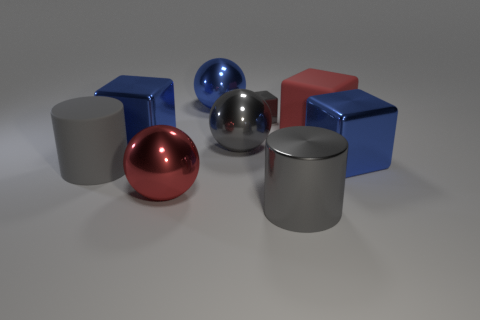Subtract 2 blocks. How many blocks are left? 2 Subtract all gray blocks. How many blocks are left? 3 Subtract all red cubes. How many cubes are left? 3 Subtract all cyan cubes. Subtract all red cylinders. How many cubes are left? 4 Add 1 small cyan things. How many objects exist? 10 Subtract all spheres. How many objects are left? 6 Subtract 1 red blocks. How many objects are left? 8 Subtract all large cyan cylinders. Subtract all big blocks. How many objects are left? 6 Add 7 gray shiny objects. How many gray shiny objects are left? 10 Add 4 gray objects. How many gray objects exist? 8 